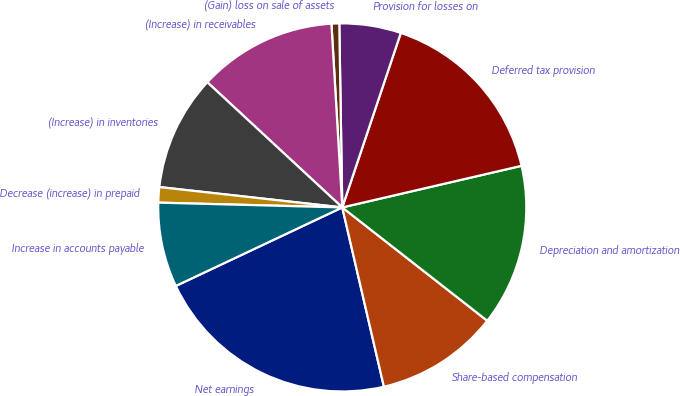Convert chart. <chart><loc_0><loc_0><loc_500><loc_500><pie_chart><fcel>Net earnings<fcel>Share-based compensation<fcel>Depreciation and amortization<fcel>Deferred tax provision<fcel>Provision for losses on<fcel>(Gain) loss on sale of assets<fcel>(Increase) in receivables<fcel>(Increase) in inventories<fcel>Decrease (increase) in prepaid<fcel>Increase in accounts payable<nl><fcel>21.62%<fcel>10.81%<fcel>14.19%<fcel>16.22%<fcel>5.41%<fcel>0.68%<fcel>12.16%<fcel>10.14%<fcel>1.35%<fcel>7.43%<nl></chart> 